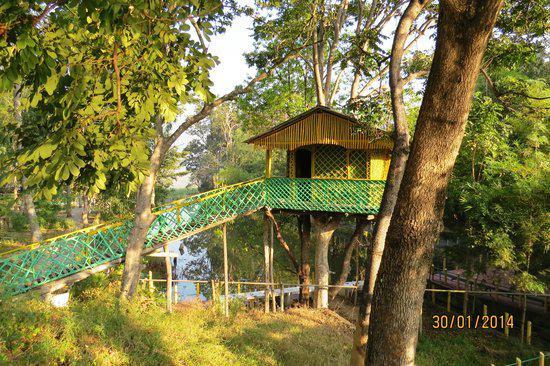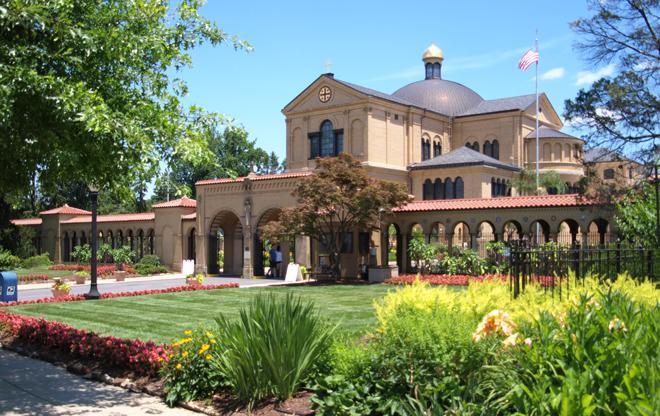The first image is the image on the left, the second image is the image on the right. For the images shown, is this caption "There is a rocky cliff in at least one image." true? Answer yes or no. No. 